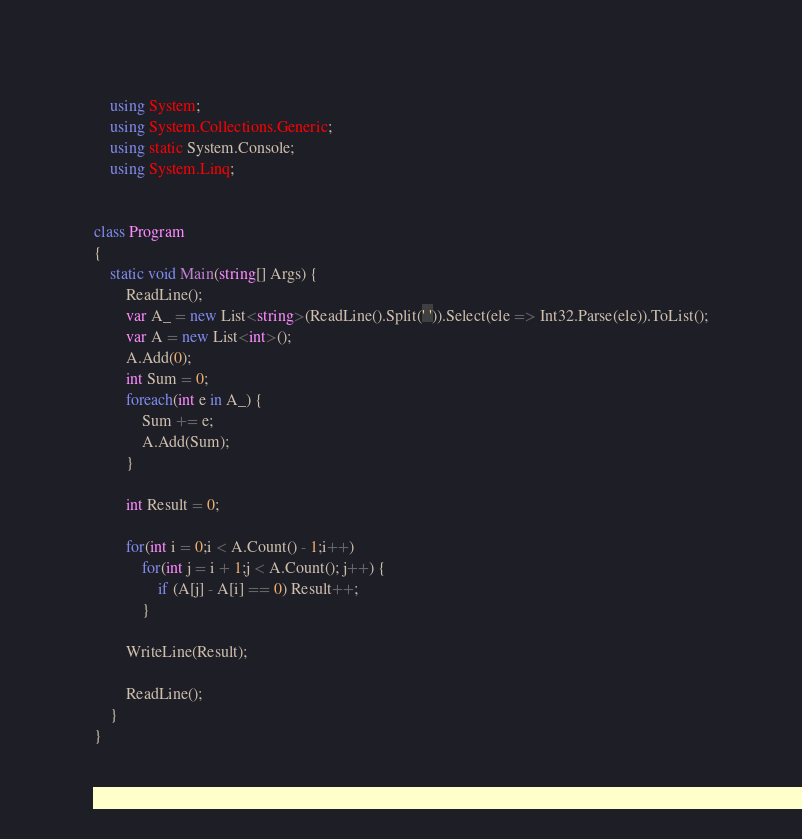<code> <loc_0><loc_0><loc_500><loc_500><_C#_>    using System;
    using System.Collections.Generic;
    using static System.Console;
    using System.Linq;


class Program
{
    static void Main(string[] Args) {
        ReadLine();
        var A_ = new List<string>(ReadLine().Split(' ')).Select(ele => Int32.Parse(ele)).ToList();
        var A = new List<int>();
        A.Add(0);
        int Sum = 0;
        foreach(int e in A_) {
            Sum += e;
            A.Add(Sum);
        }

        int Result = 0;

        for(int i = 0;i < A.Count() - 1;i++)
            for(int j = i + 1;j < A.Count(); j++) {
                if (A[j] - A[i] == 0) Result++;
            }

        WriteLine(Result);

        ReadLine();
    }
}</code> 